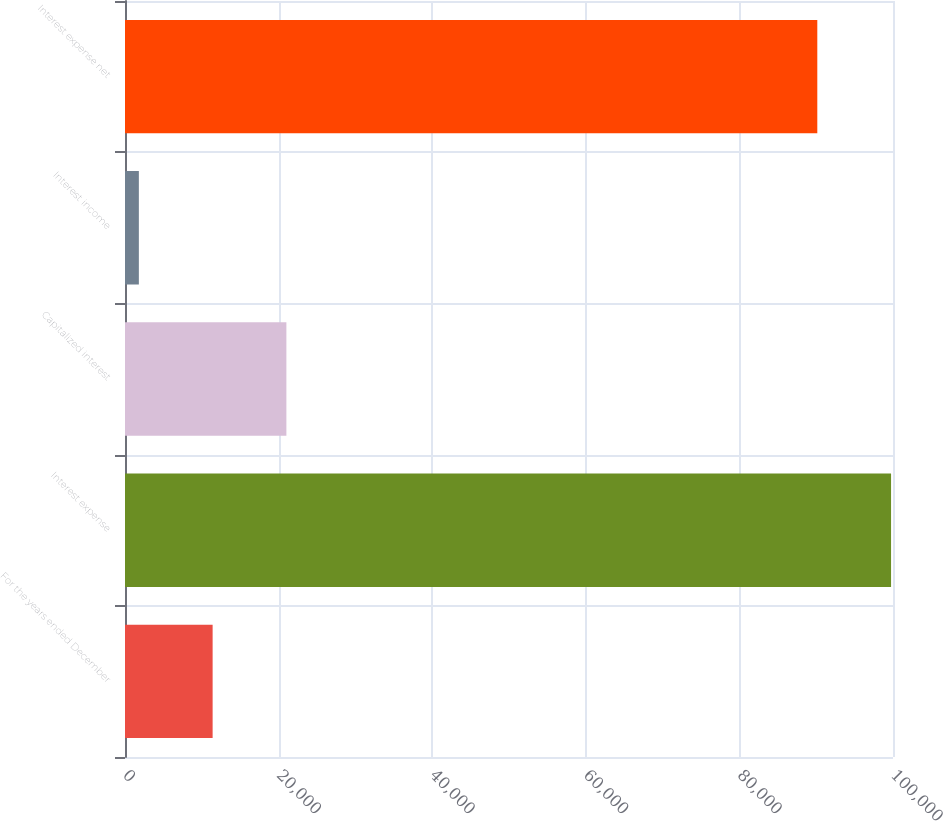Convert chart. <chart><loc_0><loc_0><loc_500><loc_500><bar_chart><fcel>For the years ended December<fcel>Interest expense<fcel>Capitalized interest<fcel>Interest income<fcel>Interest expense net<nl><fcel>11409.6<fcel>99747.6<fcel>21014.2<fcel>1805<fcel>90143<nl></chart> 